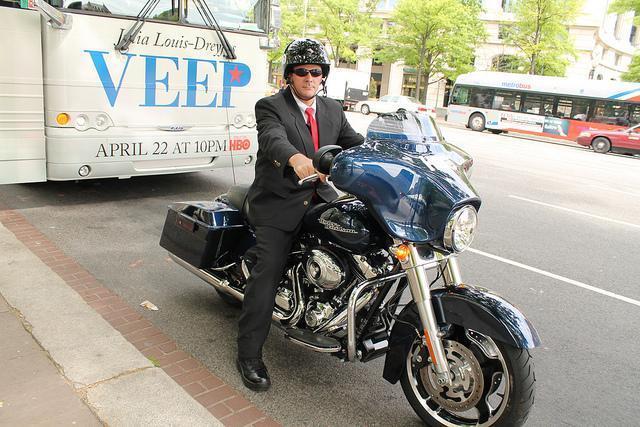How many buses are in the photo?
Give a very brief answer. 2. How many scissors are there?
Give a very brief answer. 0. 